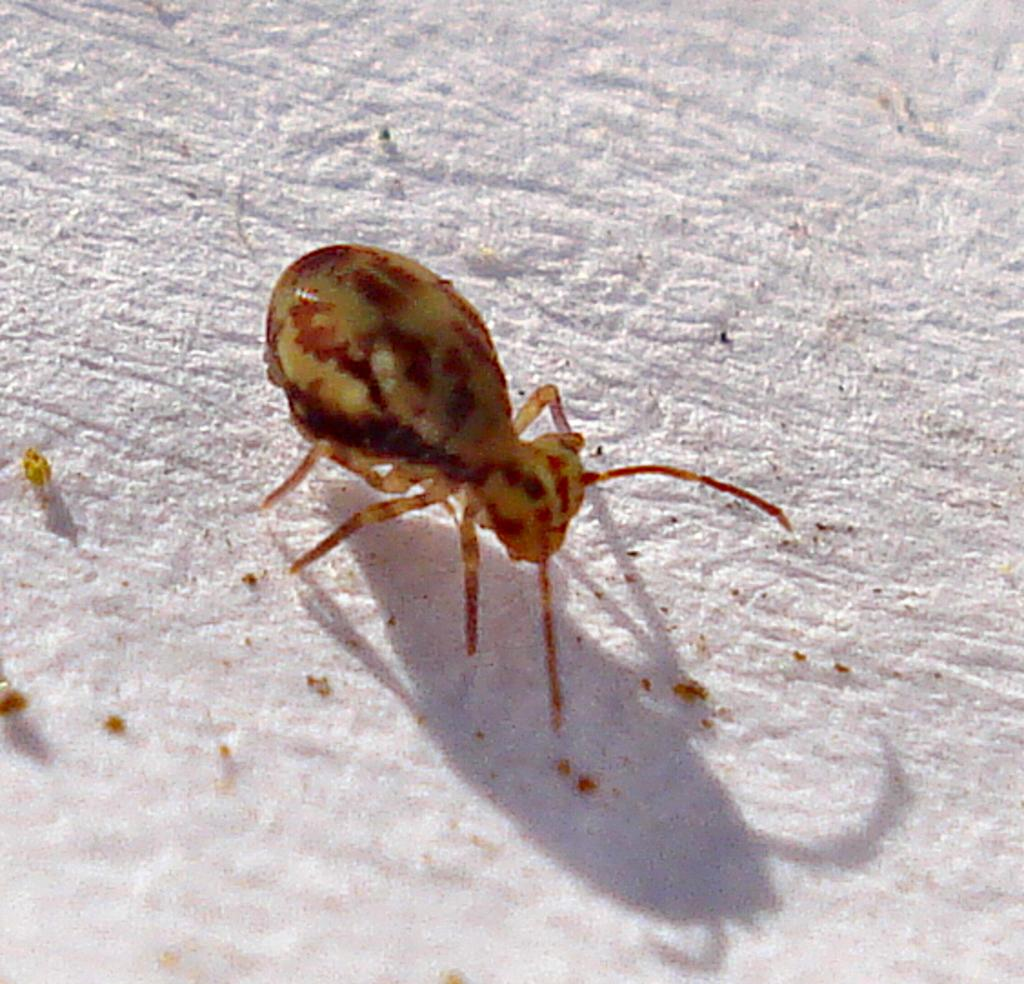What type of creature can be seen in the image? There is an insect in the image. What is the background or surface that the insect is on? The insect is on a white surface. What type of coat is the insect wearing in the image? There is no coat present in the image, as insects do not wear clothing. 